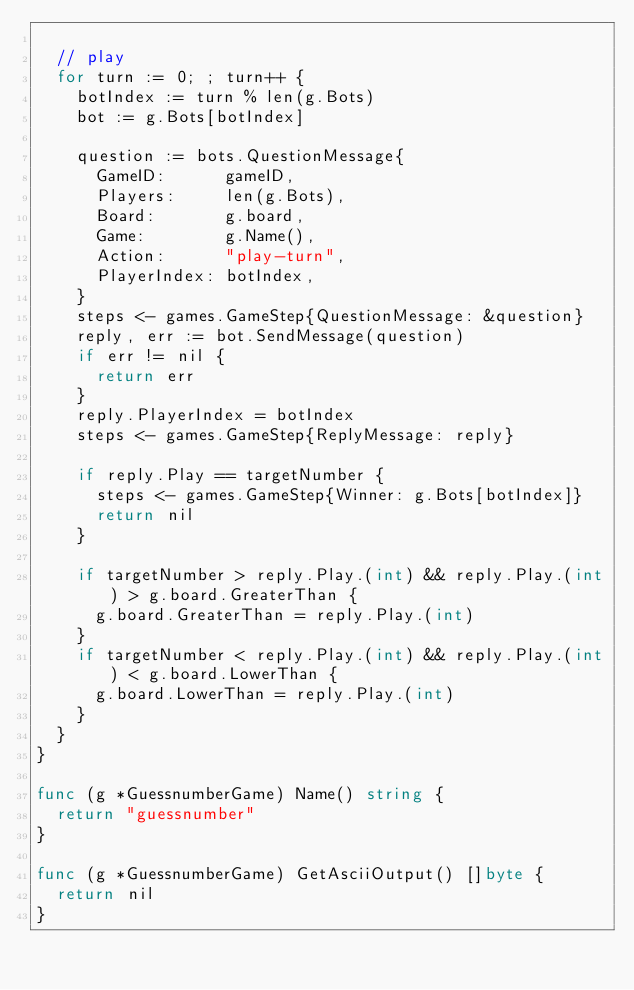Convert code to text. <code><loc_0><loc_0><loc_500><loc_500><_Go_>
	// play
	for turn := 0; ; turn++ {
		botIndex := turn % len(g.Bots)
		bot := g.Bots[botIndex]

		question := bots.QuestionMessage{
			GameID:      gameID,
			Players:     len(g.Bots),
			Board:       g.board,
			Game:        g.Name(),
			Action:      "play-turn",
			PlayerIndex: botIndex,
		}
		steps <- games.GameStep{QuestionMessage: &question}
		reply, err := bot.SendMessage(question)
		if err != nil {
			return err
		}
		reply.PlayerIndex = botIndex
		steps <- games.GameStep{ReplyMessage: reply}

		if reply.Play == targetNumber {
			steps <- games.GameStep{Winner: g.Bots[botIndex]}
			return nil
		}

		if targetNumber > reply.Play.(int) && reply.Play.(int) > g.board.GreaterThan {
			g.board.GreaterThan = reply.Play.(int)
		}
		if targetNumber < reply.Play.(int) && reply.Play.(int) < g.board.LowerThan {
			g.board.LowerThan = reply.Play.(int)
		}
	}
}

func (g *GuessnumberGame) Name() string {
	return "guessnumber"
}

func (g *GuessnumberGame) GetAsciiOutput() []byte {
	return nil
}
</code> 